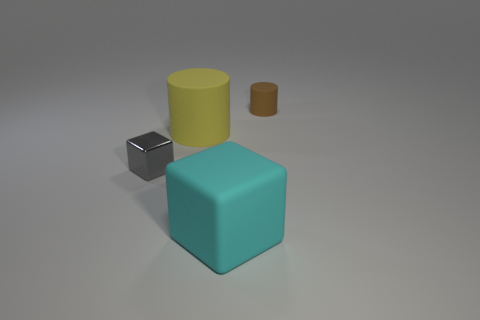What is the material of the small gray block?
Give a very brief answer. Metal. What size is the other cyan thing that is the same shape as the tiny shiny object?
Offer a very short reply. Large. There is a tiny object that is in front of the yellow cylinder; what is it made of?
Your response must be concise. Metal. The yellow matte cylinder is what size?
Keep it short and to the point. Large. What is the color of the tiny thing that is the same material as the yellow cylinder?
Give a very brief answer. Brown. How many large yellow cylinders have the same material as the cyan cube?
Offer a very short reply. 1. What number of objects are brown matte things or small brown cylinders that are behind the large cyan cube?
Provide a short and direct response. 1. Is the cube that is in front of the gray block made of the same material as the tiny cylinder?
Offer a terse response. Yes. What color is the rubber cylinder that is the same size as the cyan rubber object?
Keep it short and to the point. Yellow. Is there a large cyan matte object of the same shape as the tiny metallic thing?
Offer a very short reply. Yes. 